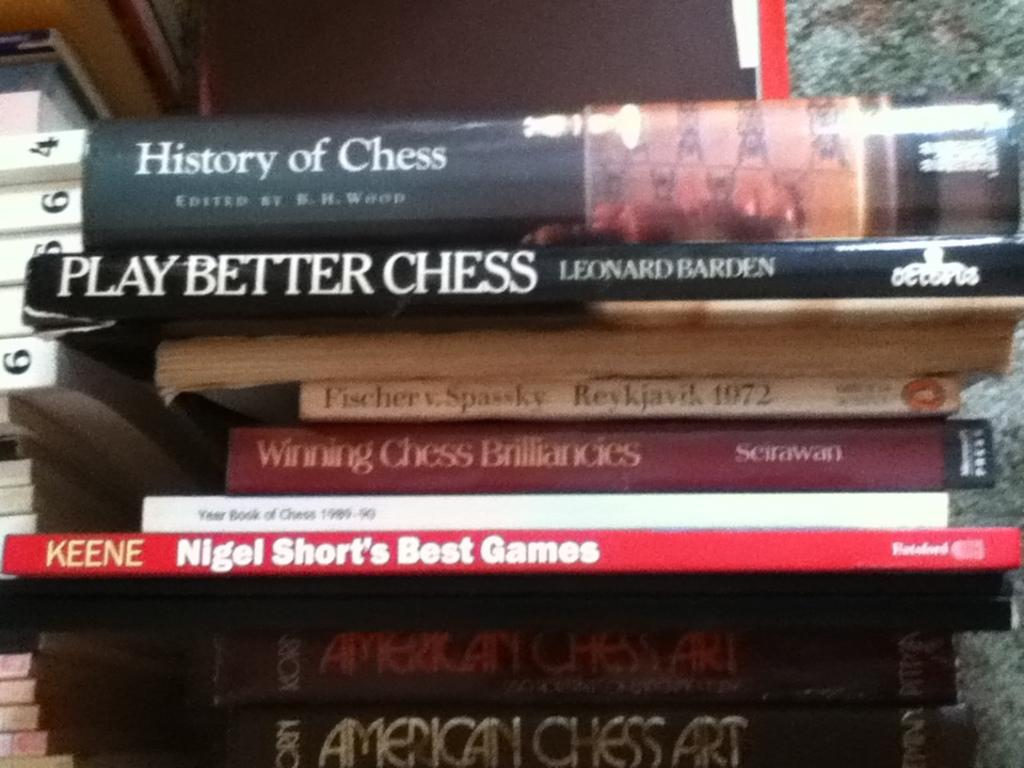Provide a one-sentence caption for the provided image. A stack of books about chess including the History of Chess. 